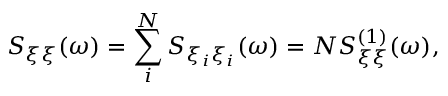Convert formula to latex. <formula><loc_0><loc_0><loc_500><loc_500>S _ { \xi \xi } ( \omega ) = \sum _ { i } ^ { N } S _ { \xi _ { i } \xi _ { i } } ( \omega ) = N S _ { \xi \xi } ^ { ( 1 ) } ( \omega ) ,</formula> 